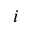Convert formula to latex. <formula><loc_0><loc_0><loc_500><loc_500>i</formula> 